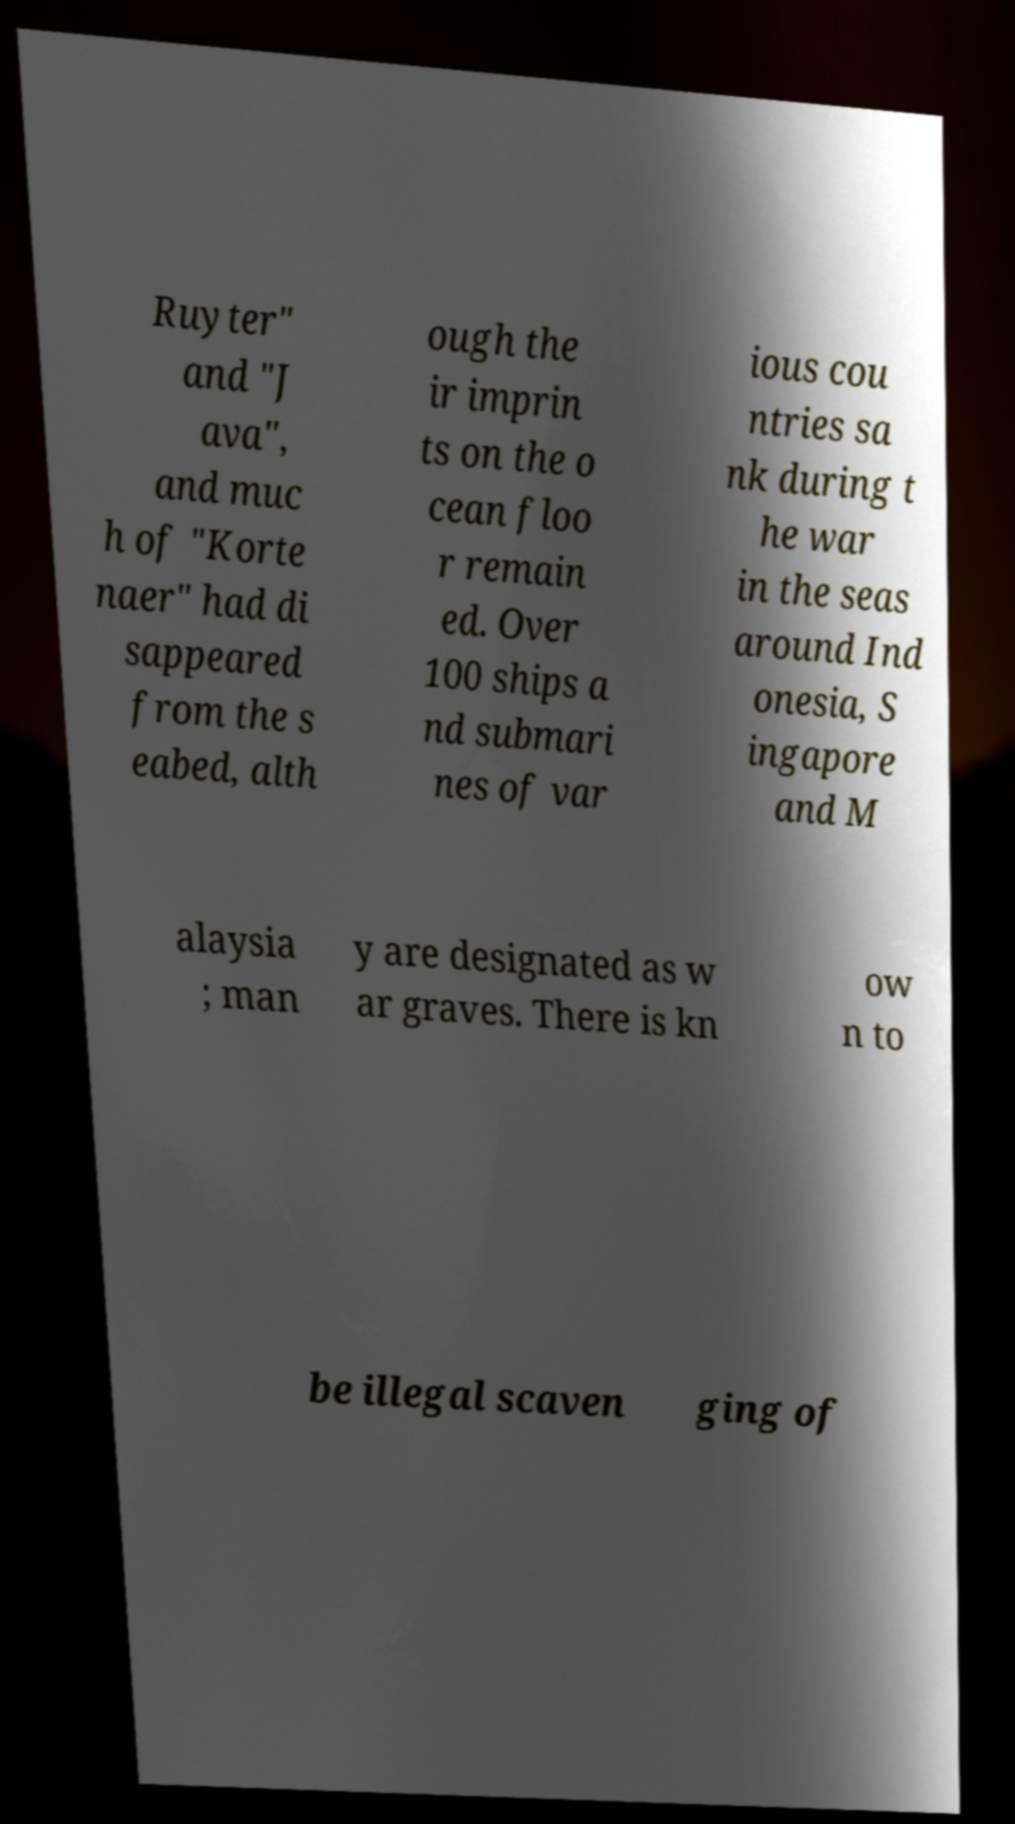Could you extract and type out the text from this image? Ruyter" and "J ava", and muc h of "Korte naer" had di sappeared from the s eabed, alth ough the ir imprin ts on the o cean floo r remain ed. Over 100 ships a nd submari nes of var ious cou ntries sa nk during t he war in the seas around Ind onesia, S ingapore and M alaysia ; man y are designated as w ar graves. There is kn ow n to be illegal scaven ging of 